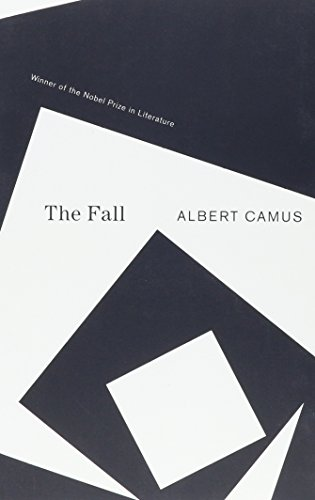Is this book related to Literature & Fiction? Yes, 'The Fall' is indeed related to Literature & Fiction, offering a rich narrative that delves into moral introspection and the human condition. 